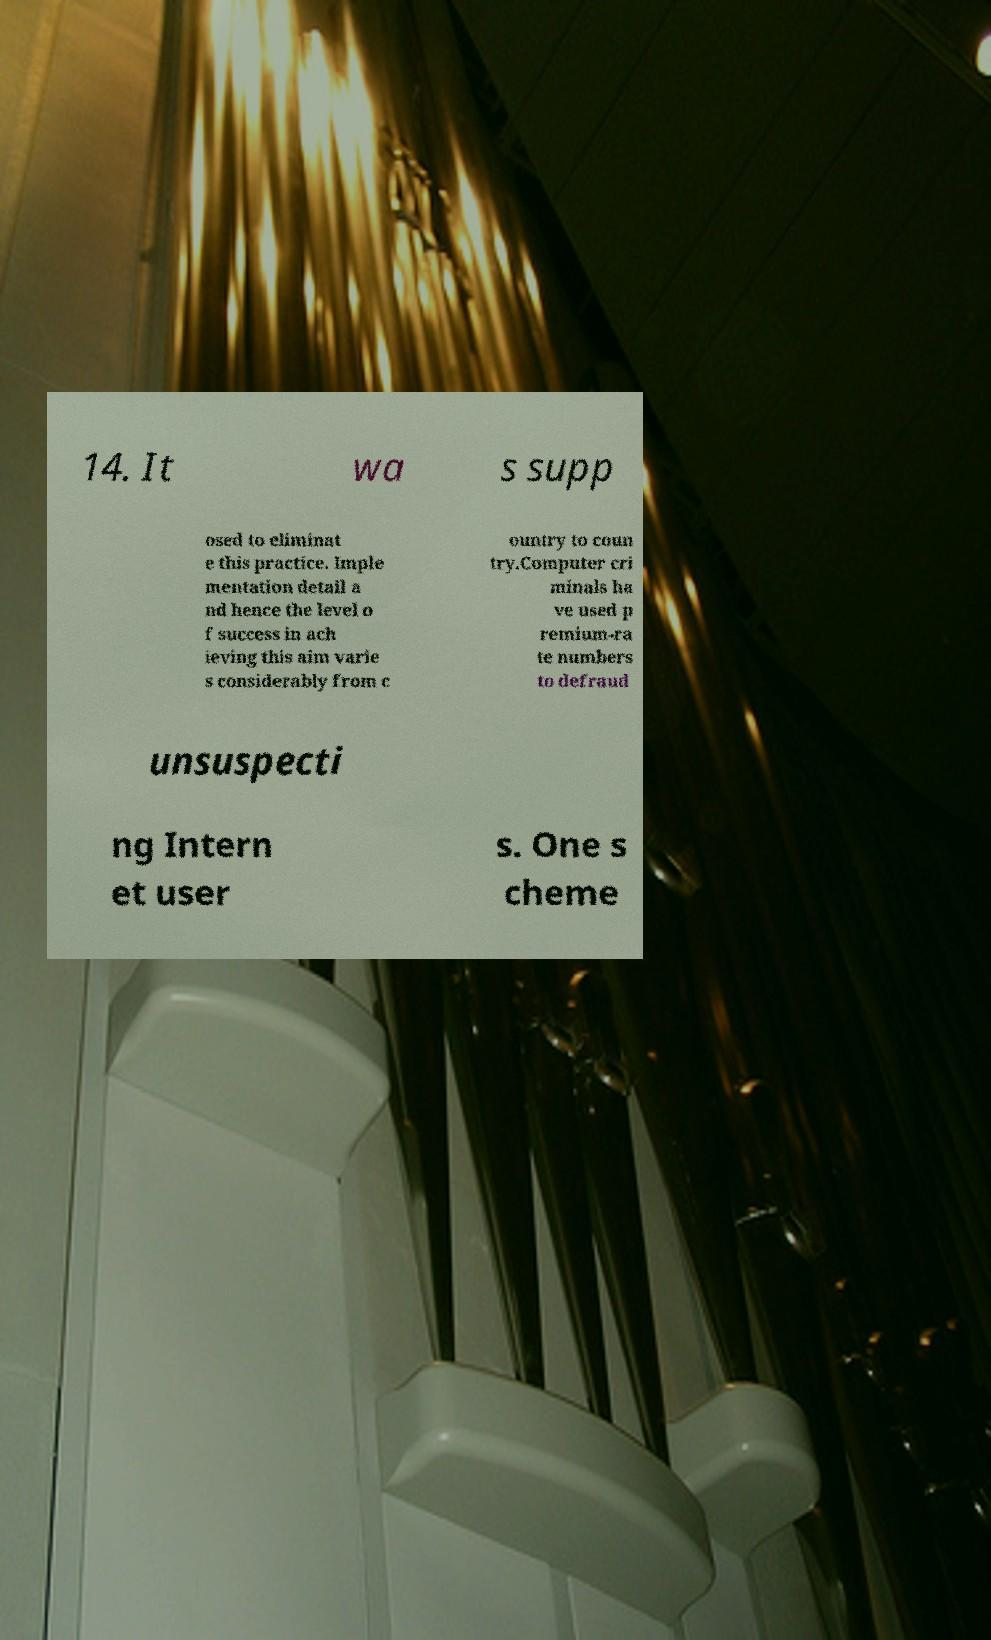Can you accurately transcribe the text from the provided image for me? 14. It wa s supp osed to eliminat e this practice. Imple mentation detail a nd hence the level o f success in ach ieving this aim varie s considerably from c ountry to coun try.Computer cri minals ha ve used p remium-ra te numbers to defraud unsuspecti ng Intern et user s. One s cheme 